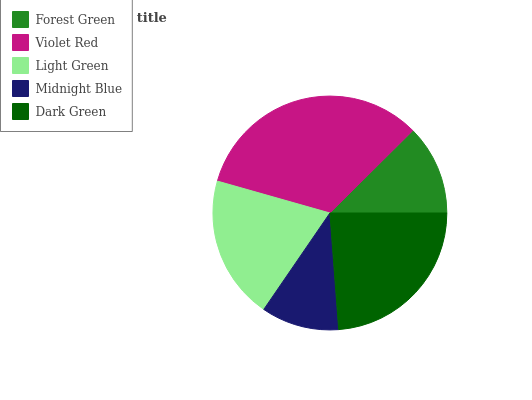Is Midnight Blue the minimum?
Answer yes or no. Yes. Is Violet Red the maximum?
Answer yes or no. Yes. Is Light Green the minimum?
Answer yes or no. No. Is Light Green the maximum?
Answer yes or no. No. Is Violet Red greater than Light Green?
Answer yes or no. Yes. Is Light Green less than Violet Red?
Answer yes or no. Yes. Is Light Green greater than Violet Red?
Answer yes or no. No. Is Violet Red less than Light Green?
Answer yes or no. No. Is Light Green the high median?
Answer yes or no. Yes. Is Light Green the low median?
Answer yes or no. Yes. Is Violet Red the high median?
Answer yes or no. No. Is Midnight Blue the low median?
Answer yes or no. No. 